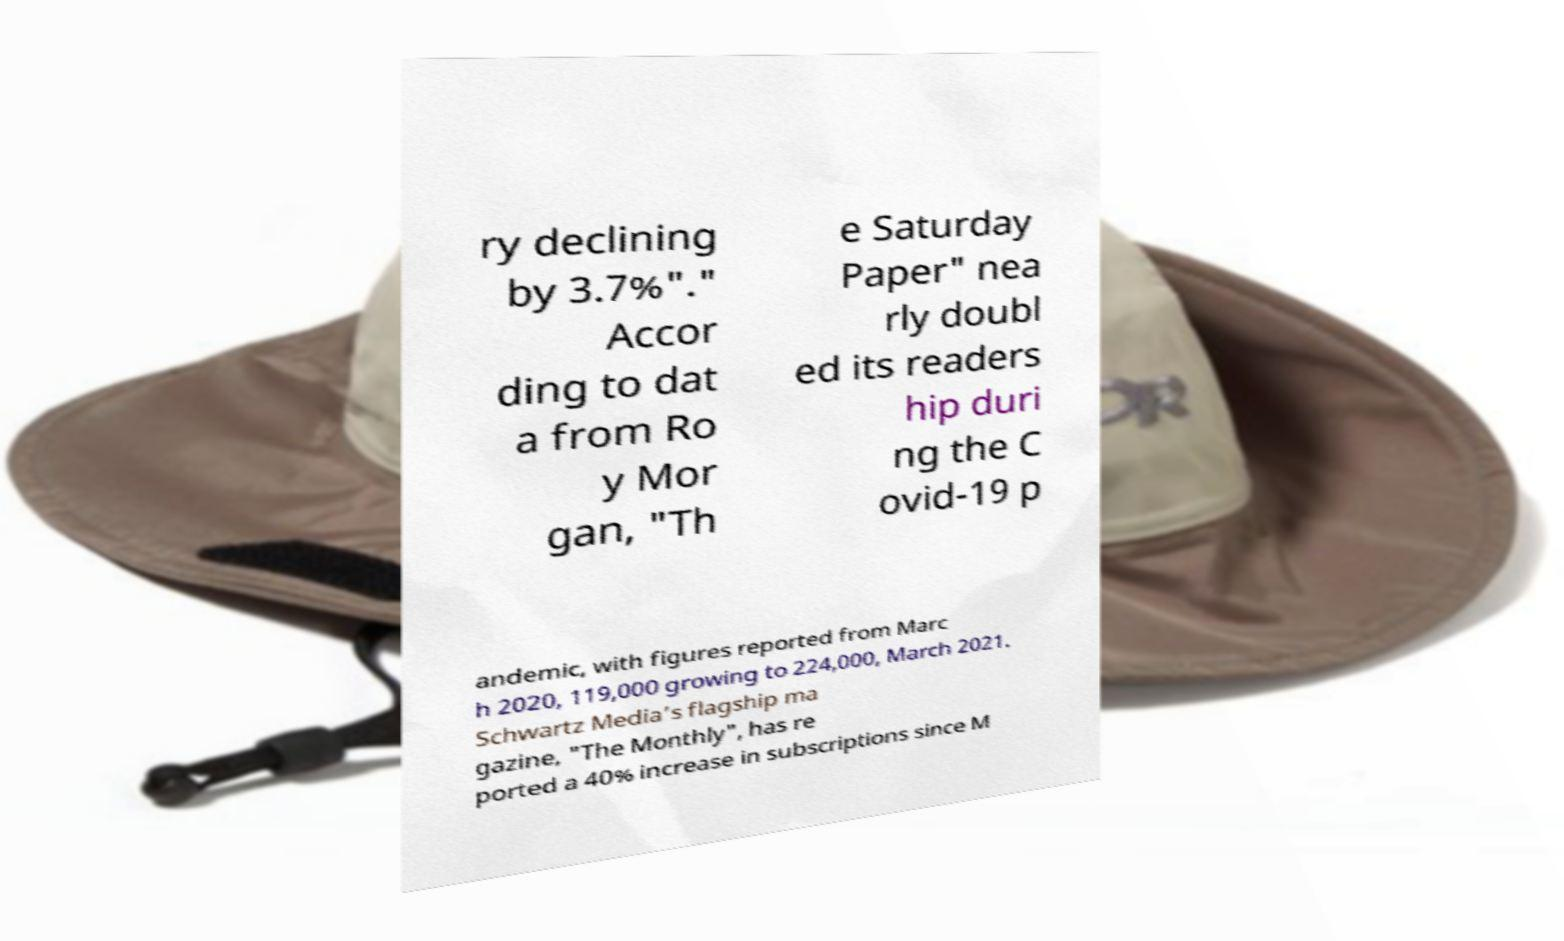Could you extract and type out the text from this image? ry declining by 3.7%"." Accor ding to dat a from Ro y Mor gan, "Th e Saturday Paper" nea rly doubl ed its readers hip duri ng the C ovid-19 p andemic, with figures reported from Marc h 2020, 119,000 growing to 224,000, March 2021. Schwartz Media’s flagship ma gazine, "The Monthly", has re ported a 40% increase in subscriptions since M 